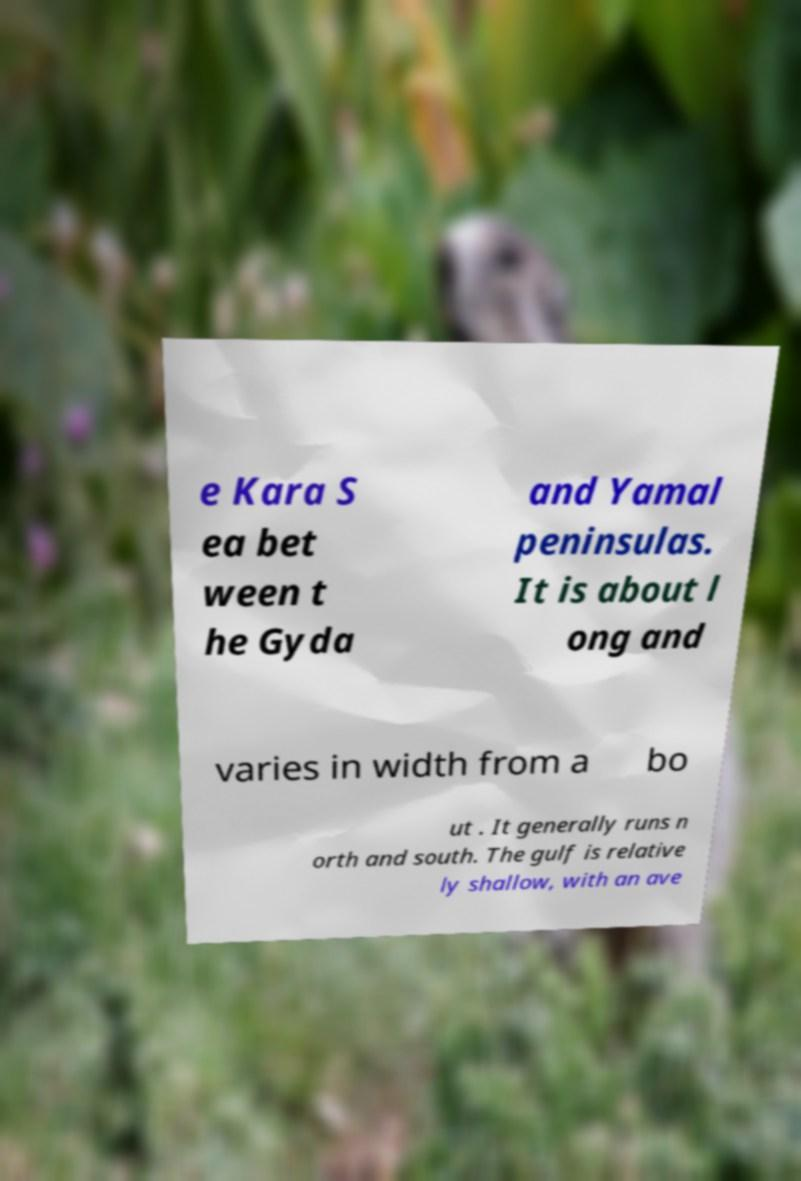Could you assist in decoding the text presented in this image and type it out clearly? e Kara S ea bet ween t he Gyda and Yamal peninsulas. It is about l ong and varies in width from a bo ut . It generally runs n orth and south. The gulf is relative ly shallow, with an ave 